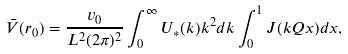<formula> <loc_0><loc_0><loc_500><loc_500>\bar { V } ( { r } _ { 0 } ) = \frac { v _ { 0 } } { L ^ { 2 } ( 2 \pi ) ^ { 2 } } \int _ { 0 } ^ { \infty } U _ { \ast } ( k ) k ^ { 2 } d k \int _ { 0 } ^ { 1 } J ( k Q x ) d x ,</formula> 